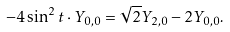<formula> <loc_0><loc_0><loc_500><loc_500>- 4 \sin ^ { 2 } t \cdot Y _ { 0 , 0 } = \sqrt { 2 } Y _ { 2 , 0 } - 2 Y _ { 0 , 0 } .</formula> 